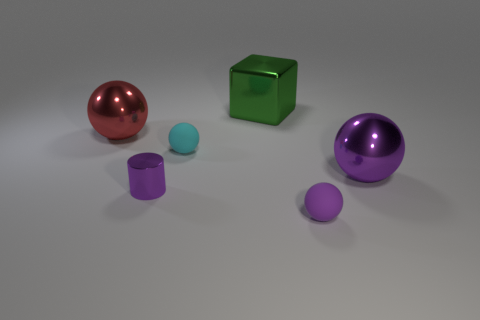There is a big red thing; are there any small purple cylinders behind it? no 